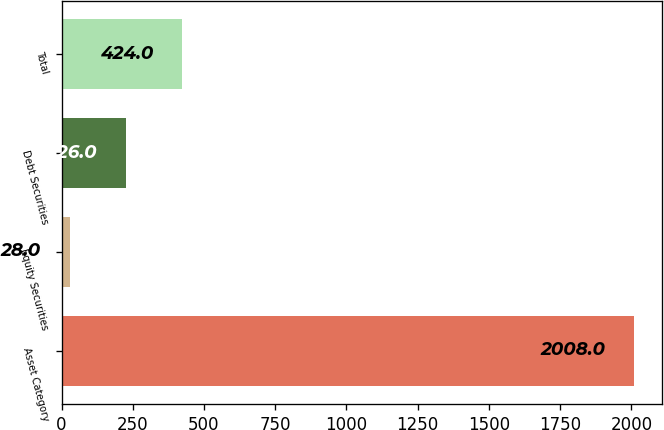Convert chart to OTSL. <chart><loc_0><loc_0><loc_500><loc_500><bar_chart><fcel>Asset Category<fcel>Equity Securities<fcel>Debt Securities<fcel>Total<nl><fcel>2008<fcel>28<fcel>226<fcel>424<nl></chart> 